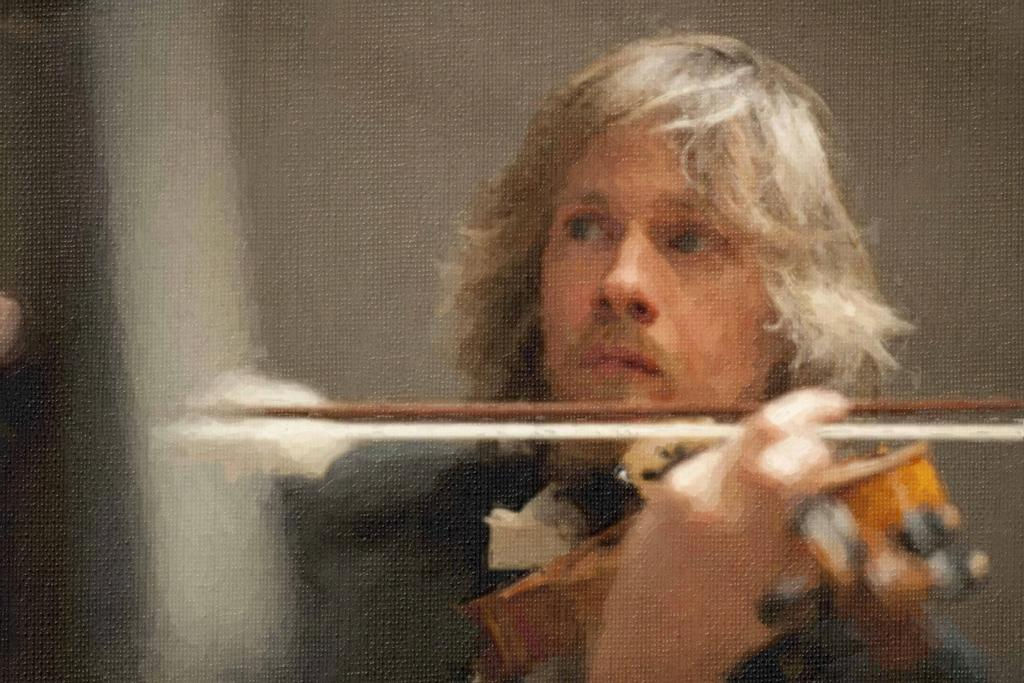What is the main subject of the image? There is a man in the image. What is the man doing in the image? The man is playing a violin. How much rice is in the basket next to the man in the image? There is no basket or rice present in the image; it only features a man playing a violin. 